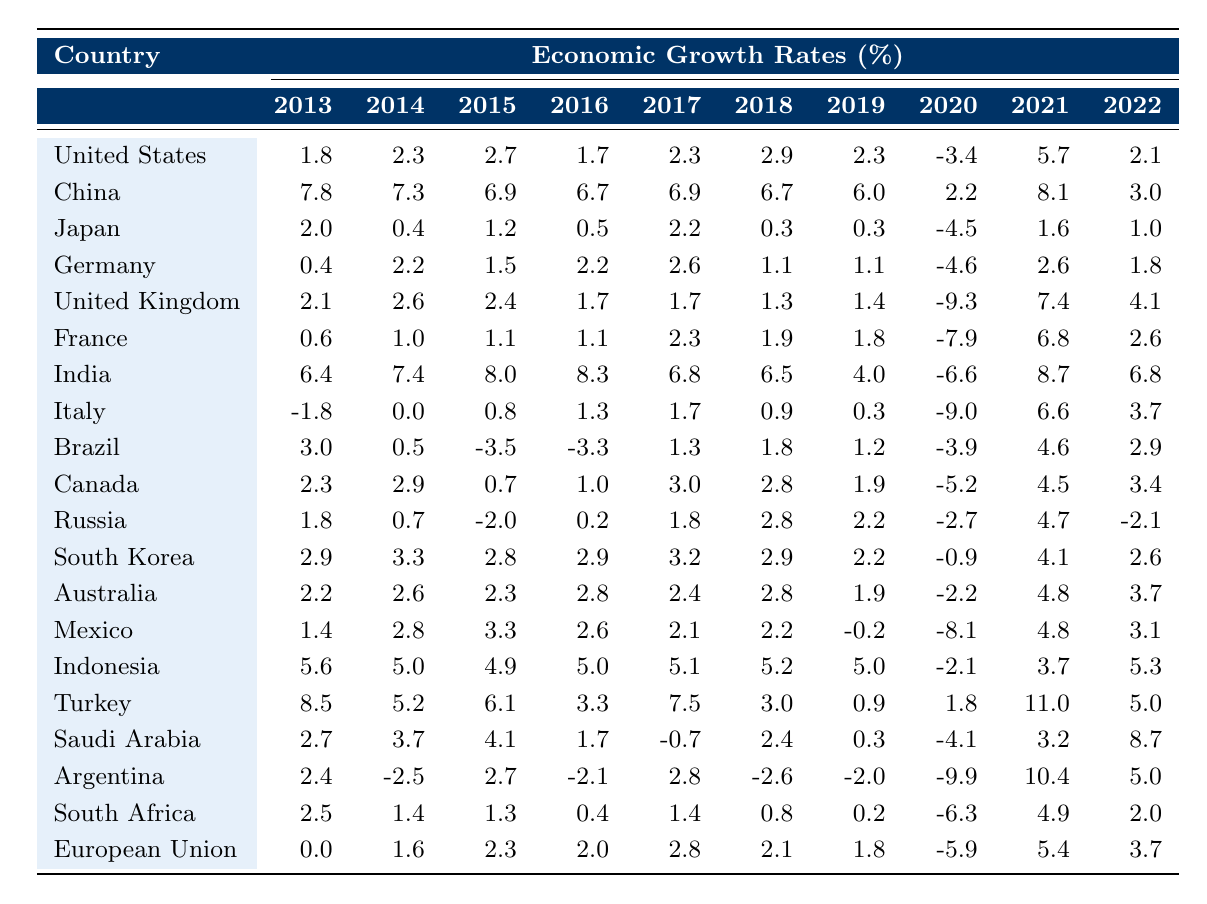What was the economic growth rate of India in 2021? According to the table, the value under India's row for the year 2021 is 8.7.
Answer: 8.7 Which country had the highest growth rate in 2013? Looking at the table, Turkey has the highest growth rate of 8.5 in the year 2013 compared to other countries listed.
Answer: Turkey What is the average economic growth rate of China over the decade? Adding China's growth rates from 2013 to 2022 gives: (7.8 + 7.3 + 6.9 + 6.7 + 6.9 + 6.7 + 6.0 + 2.2 + 8.1 + 3.0) = 57.6. Dividing by 10 (the number of years) results in an average of 5.76.
Answer: 5.76 Did Japan experience any positive growth in 2016? The table indicates that Japan's growth rate for 2016 was 0.5, which is positive.
Answer: Yes How much more did the United Kingdom grow in 2021 compared to 2020? The UK growth rate in 2021 was 7.4, while it was -9.3 in 2020. The difference is calculated as 7.4 - (-9.3) = 16.7.
Answer: 16.7 Which G20 country had the lowest growth rate in 2020? In 2020, the lowest growth rate belongs to the United Kingdom, which recorded -9.3.
Answer: United Kingdom What was the total economic growth for Indonesia across the years 2013 to 2022? Summing up Indonesia's growth rates gives: (5.6 + 5.0 + 4.9 + 5.0 + 5.1 + 5.2 + 5.0 - 2.1 + 3.7 + 5.3) = 39.7.
Answer: 39.7 Which country saw a significant increase from 2020 to 2021 placing it among the top three recoveries in growth rate? Observing the table, Argentina increased from -9.9 in 2020 to 10.4 in 2021, marking a significant recovery, while India also had a high recovery.
Answer: Argentina Was there a year (other than 2020) when the economic growth rate for South Africa was negative? Yes, the table shows that in 2020, South Africa's growth was -6.3, and in 2021 it was positive. It's the only year between 2013-2022 with a negative growth.
Answer: Yes How did Germany's 2022 growth rate compare to its 2013 growth rate? Germany's growth rate was 1.8 in 2022 and 0.4 in 2013. Therefore, 1.8 is greater than 0.4, indicating a positive upward trend since 2013.
Answer: Higher 